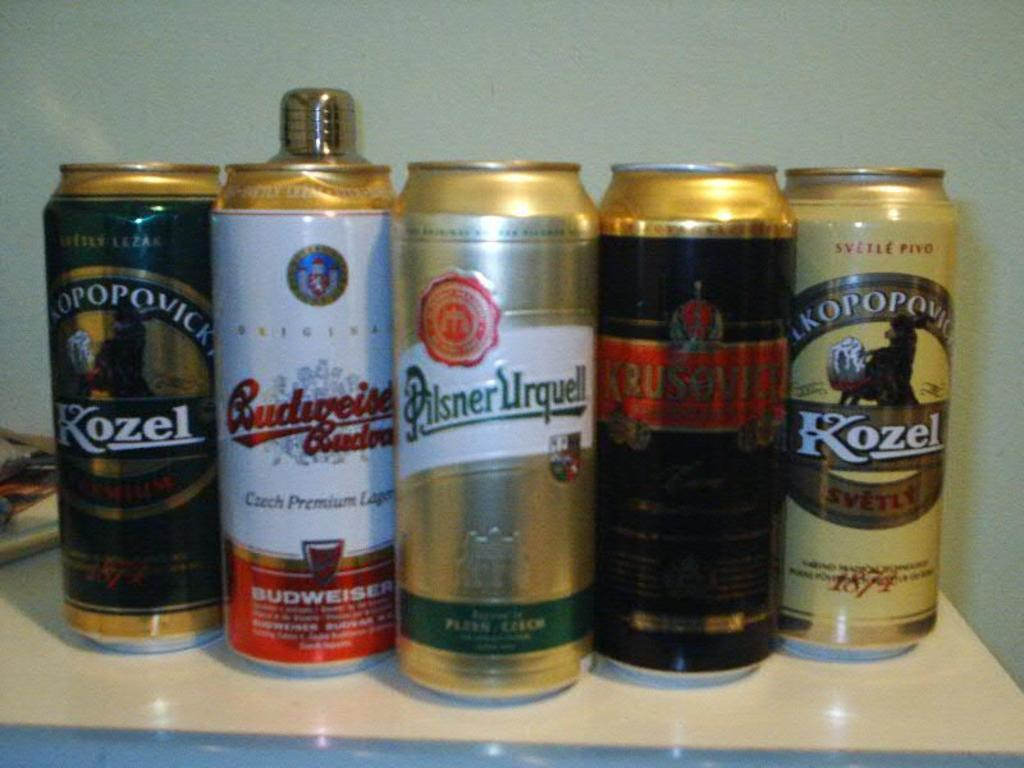<image>
Create a compact narrative representing the image presented. A number of beers including a Pisner Urquell on a counter. 